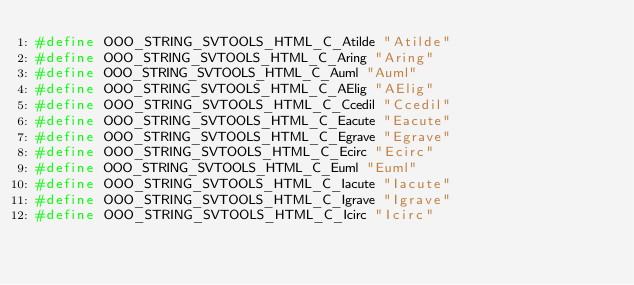<code> <loc_0><loc_0><loc_500><loc_500><_C++_>#define OOO_STRING_SVTOOLS_HTML_C_Atilde "Atilde"
#define OOO_STRING_SVTOOLS_HTML_C_Aring "Aring"
#define OOO_STRING_SVTOOLS_HTML_C_Auml "Auml"
#define OOO_STRING_SVTOOLS_HTML_C_AElig "AElig"
#define OOO_STRING_SVTOOLS_HTML_C_Ccedil "Ccedil"
#define OOO_STRING_SVTOOLS_HTML_C_Eacute "Eacute"
#define OOO_STRING_SVTOOLS_HTML_C_Egrave "Egrave"
#define OOO_STRING_SVTOOLS_HTML_C_Ecirc "Ecirc"
#define OOO_STRING_SVTOOLS_HTML_C_Euml "Euml"
#define OOO_STRING_SVTOOLS_HTML_C_Iacute "Iacute"
#define OOO_STRING_SVTOOLS_HTML_C_Igrave "Igrave"
#define OOO_STRING_SVTOOLS_HTML_C_Icirc "Icirc"</code> 